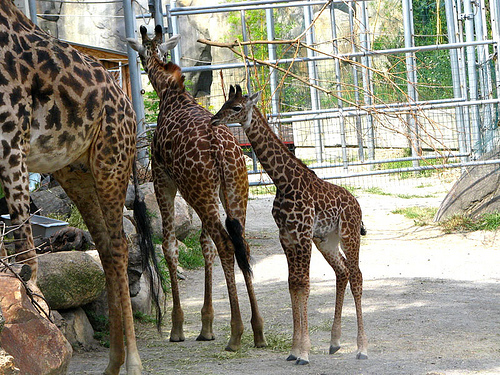How many giraffe heads are visibly looking away from the camera? In the image, there is indeed one giraffe head that is visibly looking away from the camera, which belongs to the giraffe on the right. 